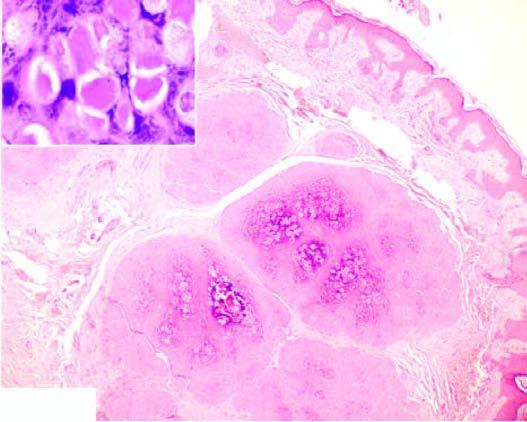what shows close-up view of molluscum bodies?
Answer the question using a single word or phrase. Inset 